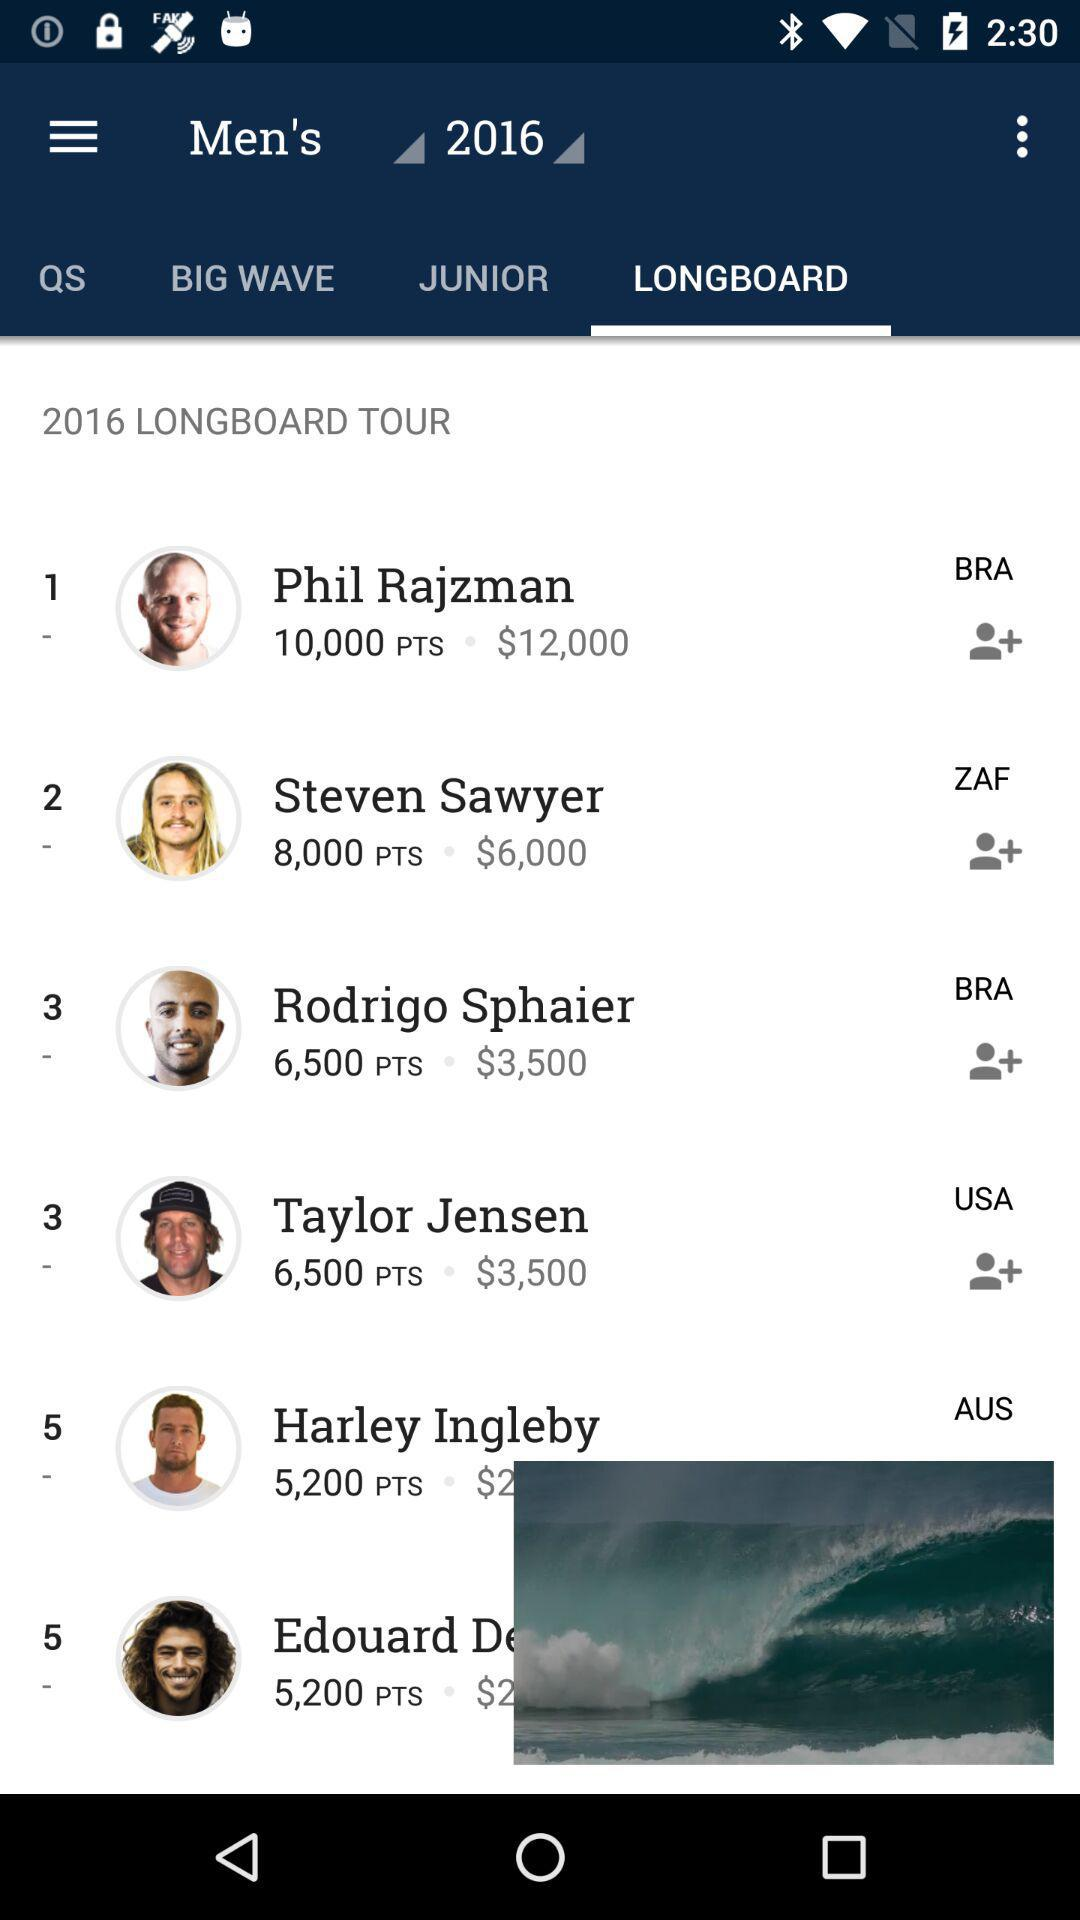How many more points does the person in 1st place have than the person in 5th place?
Answer the question using a single word or phrase. 4800 